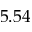Convert formula to latex. <formula><loc_0><loc_0><loc_500><loc_500>5 . 5 4</formula> 